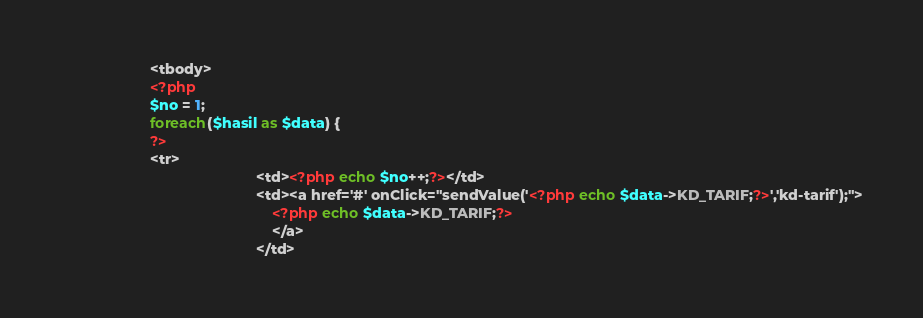Convert code to text. <code><loc_0><loc_0><loc_500><loc_500><_PHP_>                      <tbody>
					  <?php
					  $no = 1;
					  foreach($hasil as $data) {						 
					  ?>
					  <tr>
                                                <td><?php echo $no++;?></td>
                                                <td><a href='#' onClick="sendValue('<?php echo $data->KD_TARIF;?>','kd-tarif');">
                                                    <?php echo $data->KD_TARIF;?>
                                                    </a>     
                                                </td>                                                </code> 